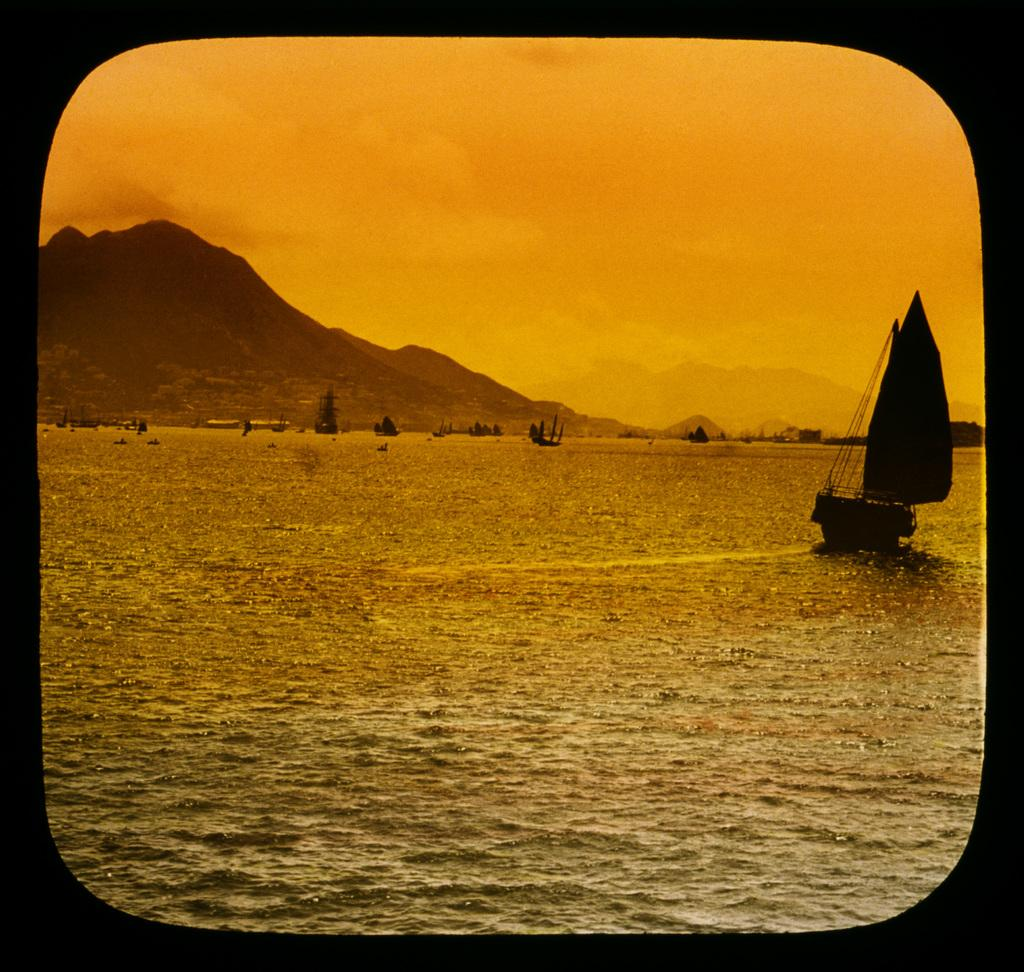What is the main subject of the image? The main subject of the image is boats. Where are the boats located? The boats are on water. What can be seen in the background of the image? Mountains and the sky are visible in the background of the image. What type of whistle can be heard coming from the boats in the image? There is no indication in the image that any whistles are being used or heard, so it cannot be determined from the picture. 